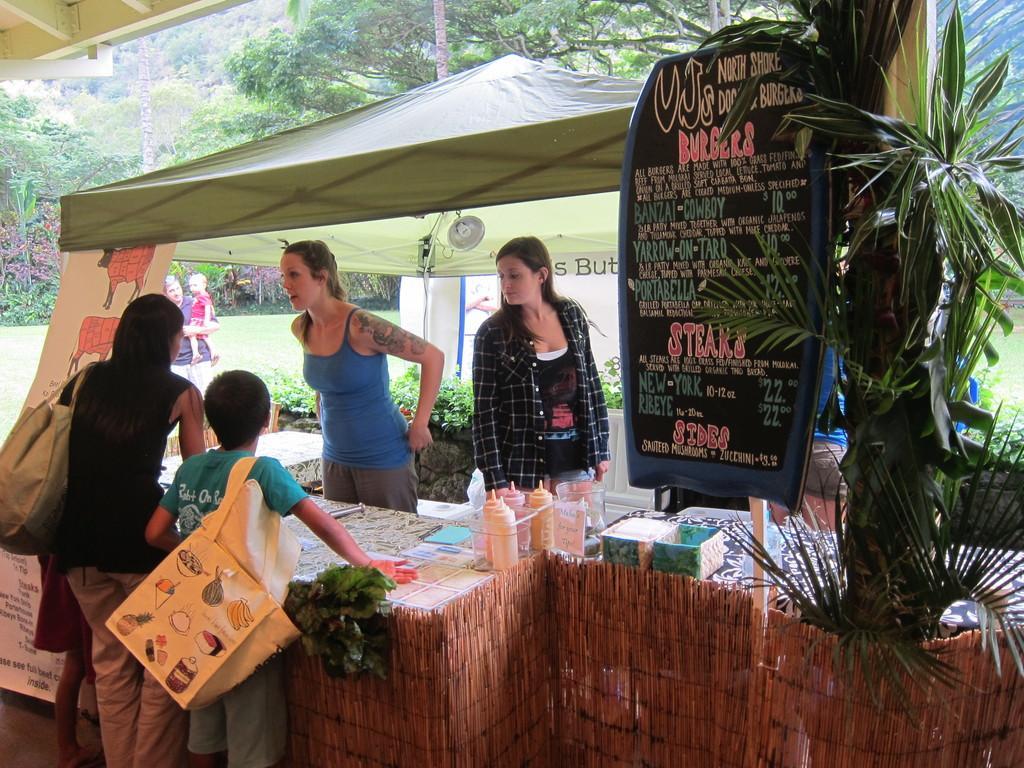How would you summarize this image in a sentence or two? In this image we can see people, tables, information boards, plants, trees, tent and things. Far a person is carrying a baby. In the front two people wore bags. Above the table there are boxes, bottles and things. 